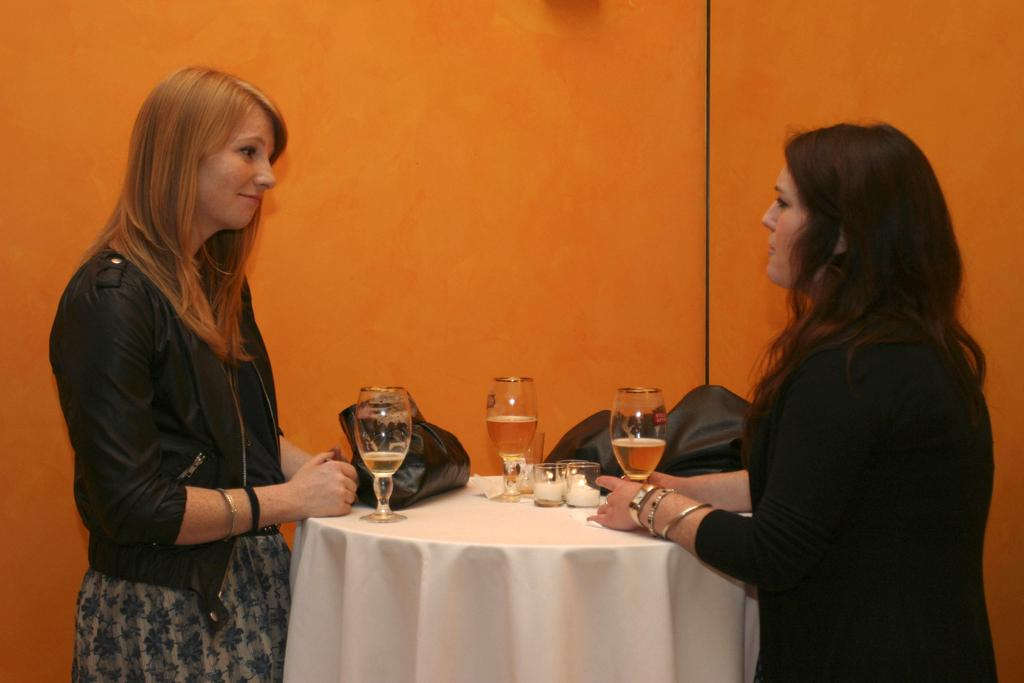How many people are in the image? There are 2 people standing in front of a table. What is on the table in the image? There are bags, a glass, and candles on the table. What type of current is flowing through the candles in the image? There is no current flowing through the candles in the image; they are likely lit by a flame. 